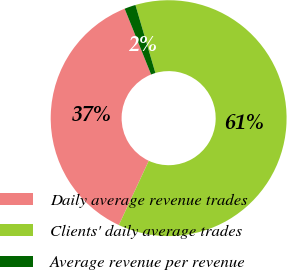<chart> <loc_0><loc_0><loc_500><loc_500><pie_chart><fcel>Daily average revenue trades<fcel>Clients' daily average trades<fcel>Average revenue per revenue<nl><fcel>36.98%<fcel>61.48%<fcel>1.54%<nl></chart> 